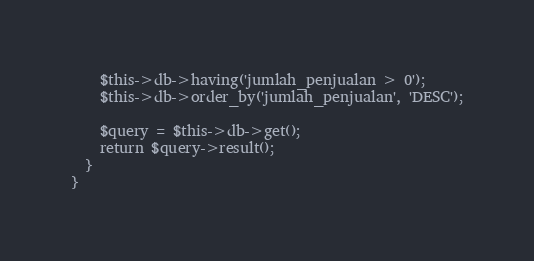<code> <loc_0><loc_0><loc_500><loc_500><_PHP_>    $this->db->having('jumlah_penjualan > 0');
    $this->db->order_by('jumlah_penjualan', 'DESC');

    $query = $this->db->get();
    return $query->result();
  }
}
</code> 